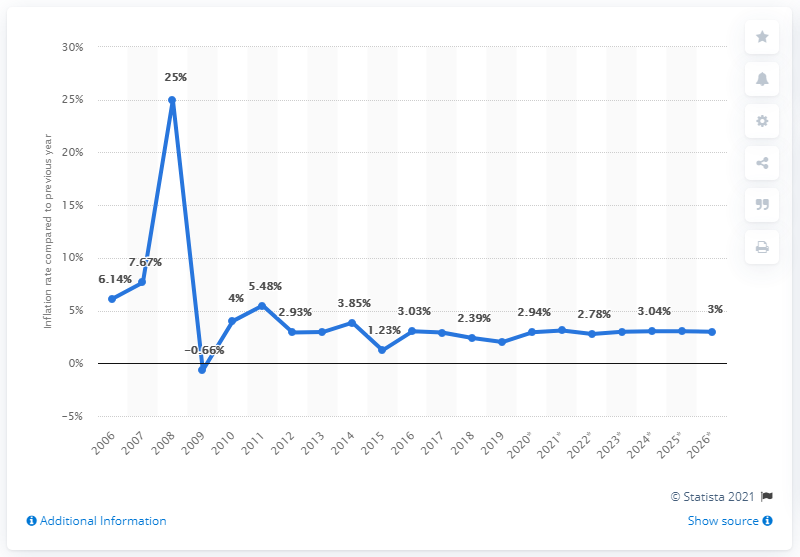Indicate a few pertinent items in this graphic. In 2006, the average inflation rate in Cambodia was X. 